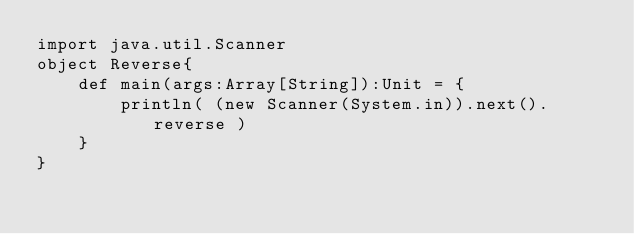Convert code to text. <code><loc_0><loc_0><loc_500><loc_500><_Scala_>import java.util.Scanner
object Reverse{
    def main(args:Array[String]):Unit = {
        println( (new Scanner(System.in)).next().reverse )
    }
}</code> 